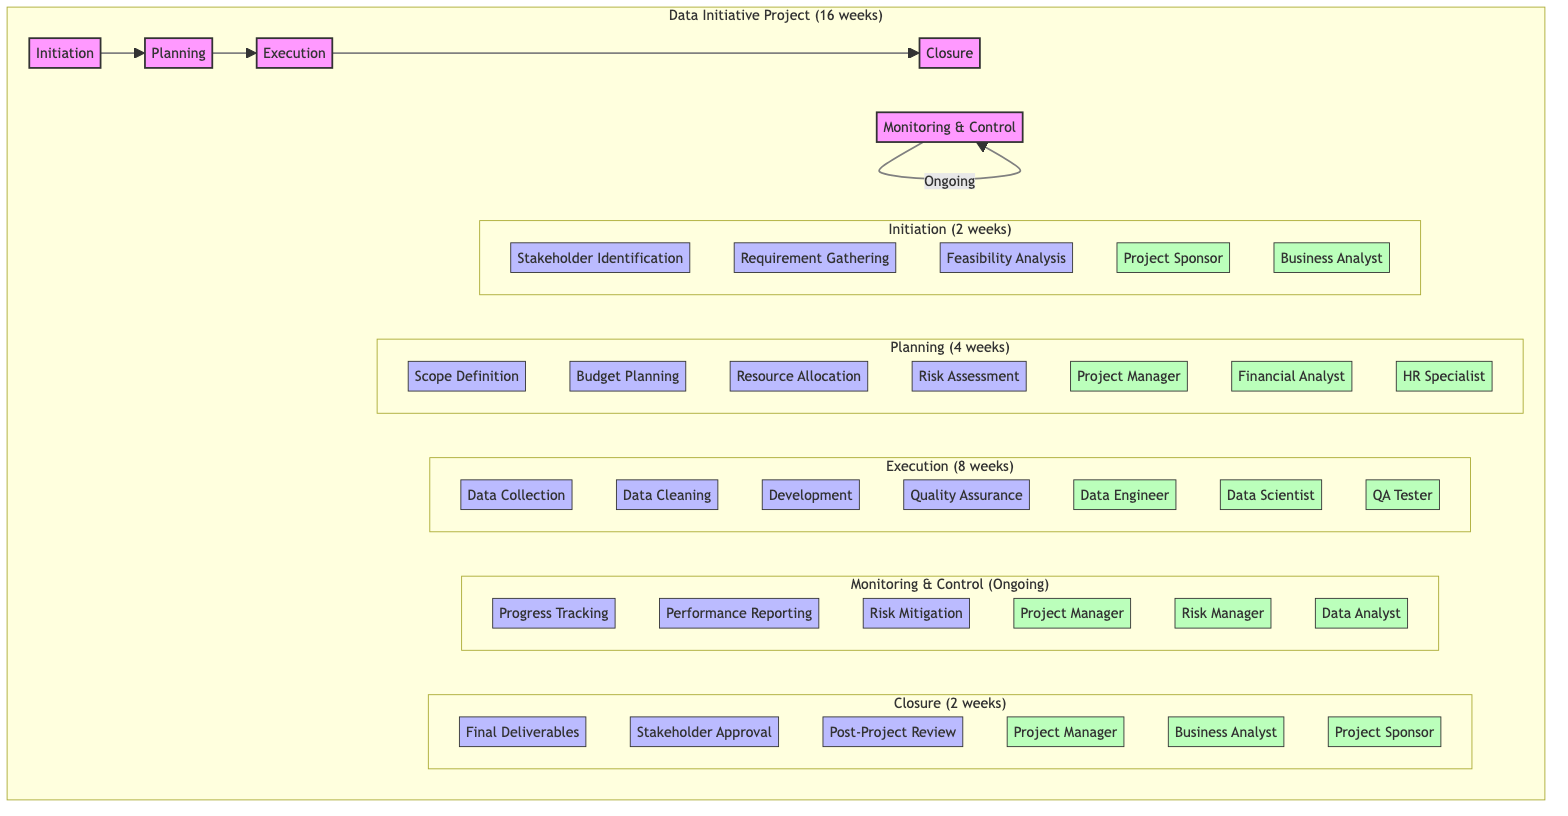What is the total duration of the project? The overall project duration is indicated as "16 weeks" in the diagram, which encompasses all phases of the project from initiation to closure.
Answer: 16 weeks What key resources are involved in the Execution phase? The diagram shows that the key resources in the Execution phase include a Data Engineer, Data Scientist, and QA Tester, which are specifically listed in that section of the diagram.
Answer: Data Engineer, Data Scientist, QA Tester How many tasks are there in the Planning phase? In the Planning phase, there are four tasks presented, namely Scope Definition, Budget Planning, Resource Allocation, and Risk Assessment, as visible under that phase in the diagram.
Answer: 4 Which phase follows the Initiation phase? The diagram indicates a directional flow from the Initiation phase to the Planning phase, representing that Planning occurs immediately after Initiation.
Answer: Planning What is an ongoing activity in the project? The Monitoring & Control phase is noted as ongoing in the diagram, suggesting that activities under this phase, such as Progress Tracking and Risk Mitigation, continue throughout the project.
Answer: Ongoing What is the last task in the Closure phase? The last task listed in the Closure phase is the Post-Project Review, clearly labeled as the third task in that specific phase of the diagram.
Answer: Post-Project Review Which role is responsible for Risk Mitigation? The role responsible for Risk Mitigation is the Risk Manager, as indicated within the Monitoring & Control section of the diagram where the resources are outlined.
Answer: Risk Manager How many key resources are there in the Planning phase? The Planning phase has three key resources listed: Project Manager, Financial Analyst, and HR Specialist, showing the division of roles for the tasks in that phase.
Answer: 3 What task is primarily associated with data handling in Execution? The Data Collection task is specifically associated with data handling in the Execution phase, focusing on gathering data needed for the project, as labeled in the diagram.
Answer: Data Collection 